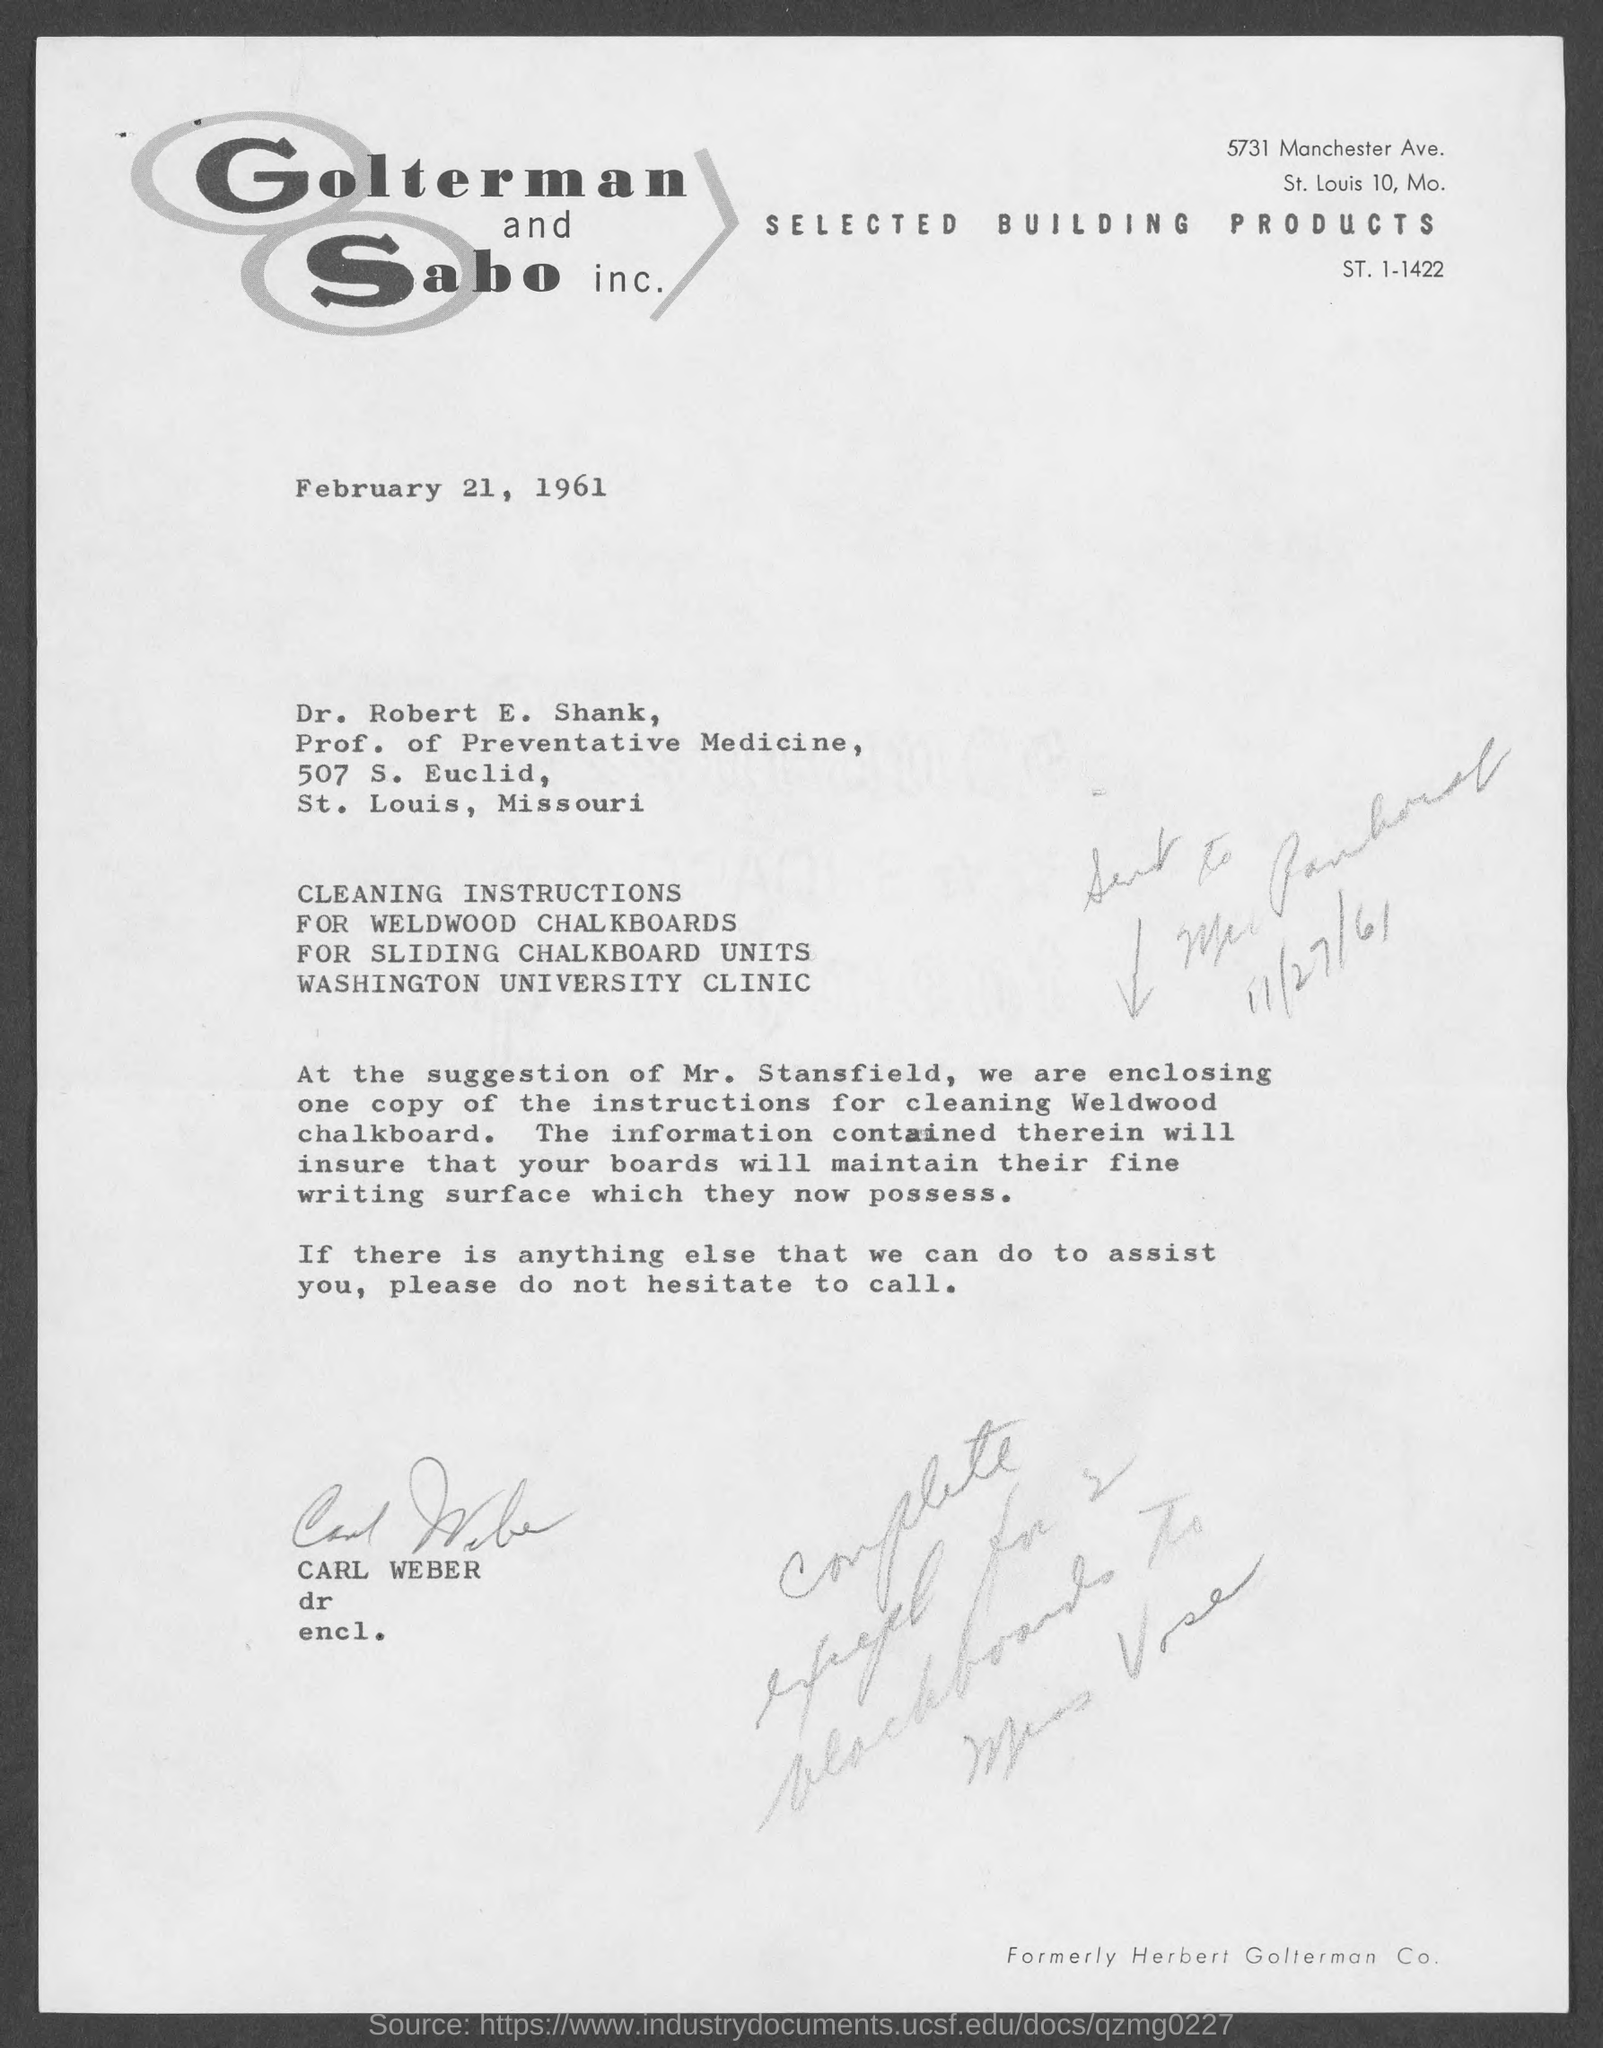Outline some significant characteristics in this image. The letter is addressed to Dr. Robert E. Shank. It is Prof. Dr. Robert E. Shank who is recognized as a Professor of Preventative Medicine. The date of the letter is February 21, 1961. Who sent the letter?" asked Carl Weber. 